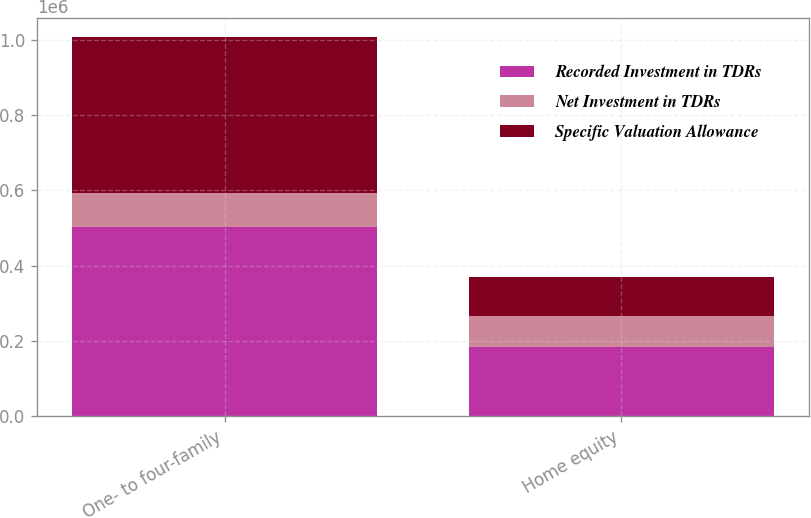Convert chart to OTSL. <chart><loc_0><loc_0><loc_500><loc_500><stacked_bar_chart><ecel><fcel>One- to four-family<fcel>Home equity<nl><fcel>Recorded Investment in TDRs<fcel>503557<fcel>185133<nl><fcel>Net Investment in TDRs<fcel>89684<fcel>81690<nl><fcel>Specific Valuation Allowance<fcel>413873<fcel>103443<nl></chart> 